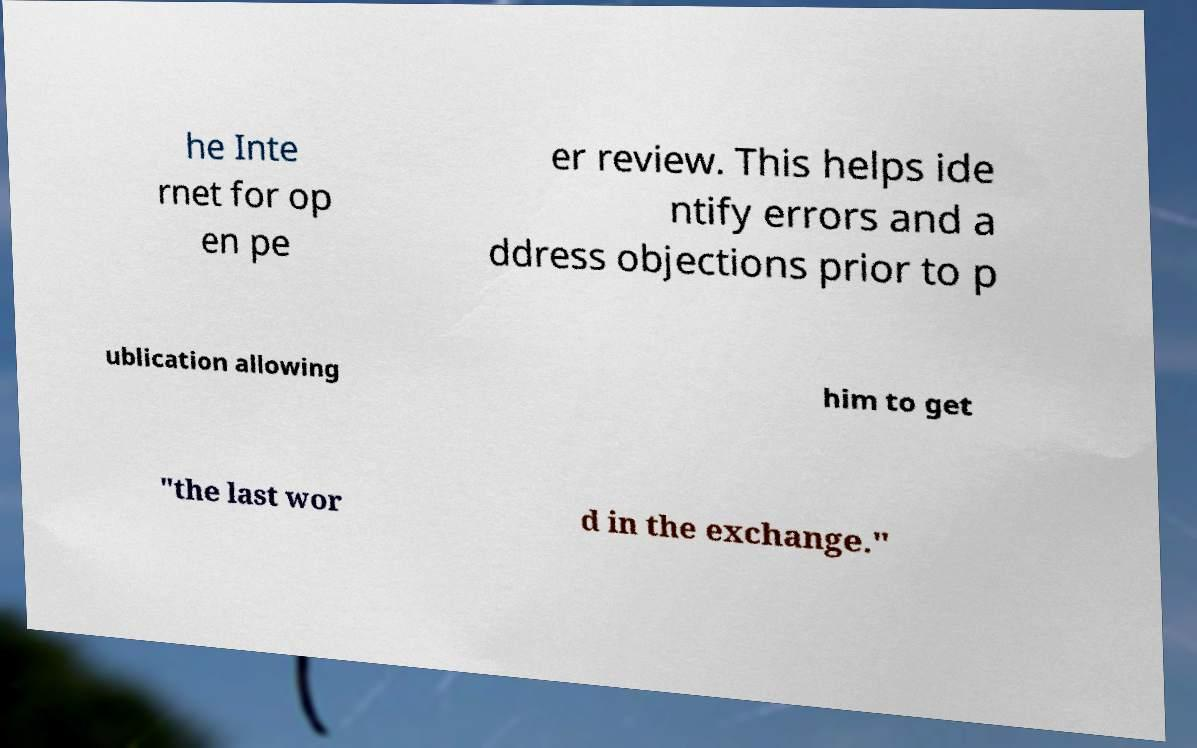There's text embedded in this image that I need extracted. Can you transcribe it verbatim? he Inte rnet for op en pe er review. This helps ide ntify errors and a ddress objections prior to p ublication allowing him to get "the last wor d in the exchange." 